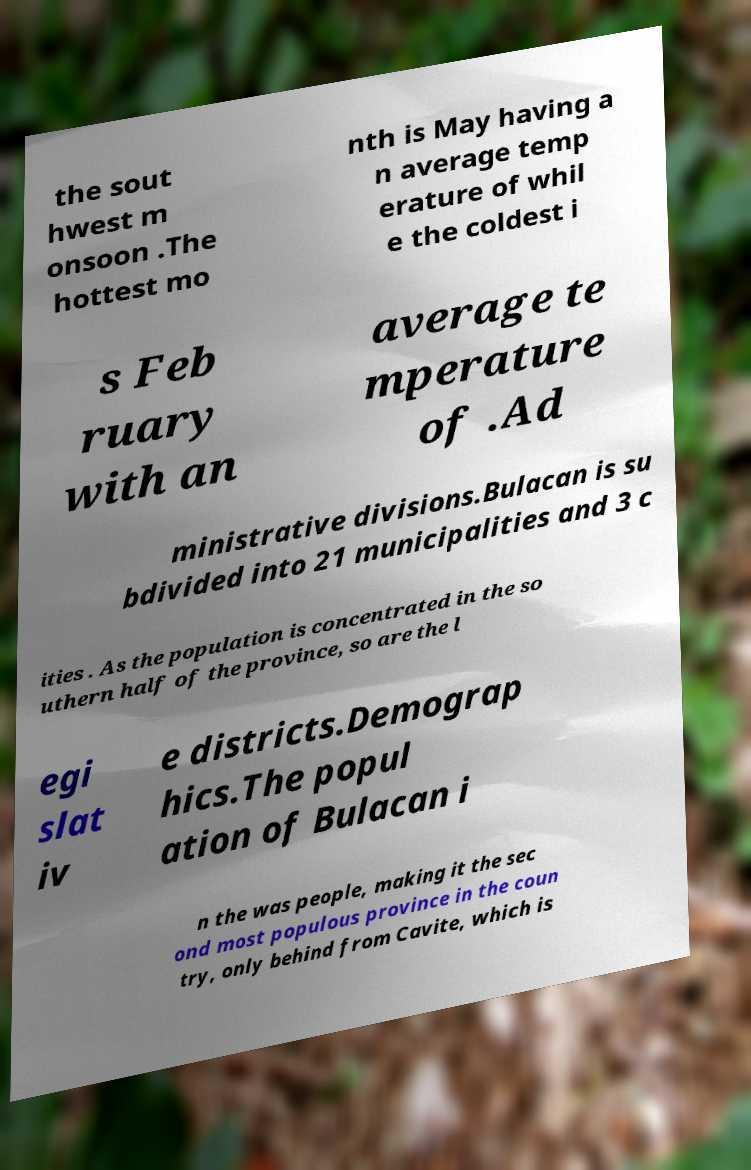Can you accurately transcribe the text from the provided image for me? the sout hwest m onsoon .The hottest mo nth is May having a n average temp erature of whil e the coldest i s Feb ruary with an average te mperature of .Ad ministrative divisions.Bulacan is su bdivided into 21 municipalities and 3 c ities . As the population is concentrated in the so uthern half of the province, so are the l egi slat iv e districts.Demograp hics.The popul ation of Bulacan i n the was people, making it the sec ond most populous province in the coun try, only behind from Cavite, which is 